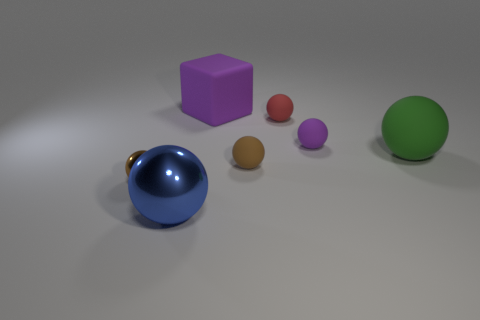Subtract all small shiny balls. How many balls are left? 5 Subtract all cyan cylinders. How many brown balls are left? 2 Add 1 large brown objects. How many objects exist? 8 Subtract all red spheres. How many spheres are left? 5 Subtract all spheres. How many objects are left? 1 Subtract all blue spheres. Subtract all gray blocks. How many spheres are left? 5 Add 4 green matte cylinders. How many green matte cylinders exist? 4 Subtract 0 red blocks. How many objects are left? 7 Subtract all small brown metallic spheres. Subtract all blue objects. How many objects are left? 5 Add 1 small rubber things. How many small rubber things are left? 4 